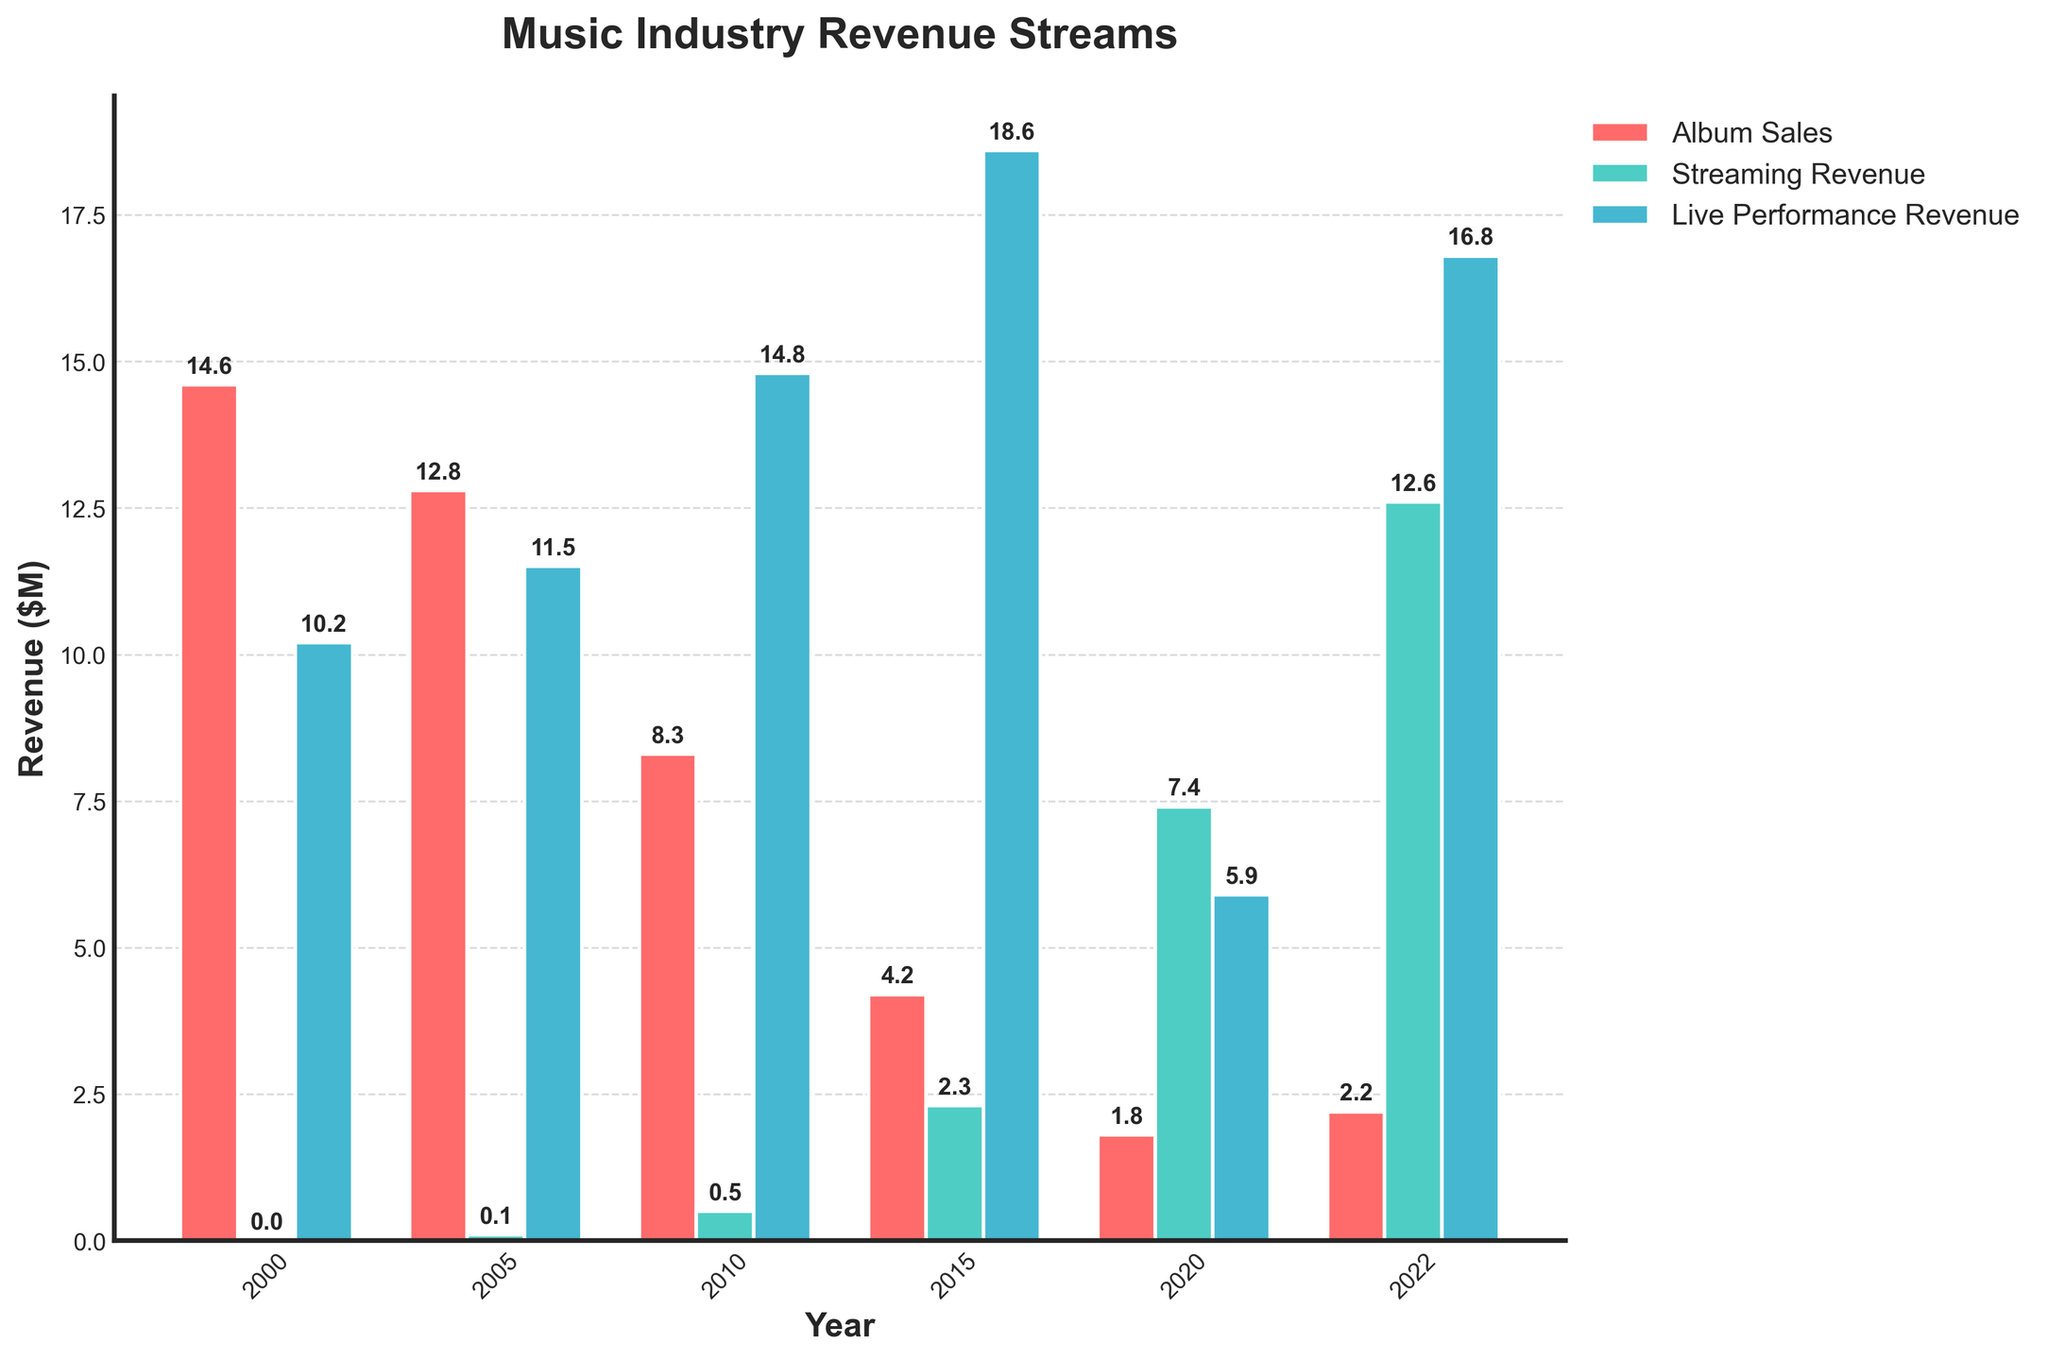What was the revenue from album sales in 2000? The bar representing album sales in the year 2000 shows a height labeling of 14.6.
Answer: 14.6 Which year had the highest streaming revenue? Among the bars representing streaming revenue across all the years, the highest bar is in 2022, labeled 12.6.
Answer: 2022 How did the revenue from live performances in 2005 compare to that in 2020? The bar for live performance revenue in 2005 is 11.5, and the bar in 2020 is 5.9. By comparing them, we see that revenue was higher in 2005.
Answer: Higher in 2005 Which revenue stream showed the most consistent increase over the years? Streaming revenue started from almost zero in 2000 and consistently increased to 12.6 by 2022. Both album sales and live performance revenue fluctuated.
Answer: Streaming revenue What is the difference between the album sales revenue and live performance revenue in 2010? The album sales revenue in 2010 is 8.3, and the live performance revenue is 14.8. The difference is 14.8 - 8.3.
Answer: 6.5 How much more was the streaming revenue compared to album sales in 2020? In 2020, streaming revenue was 7.4, and album sales were 1.8. The difference is 7.4 - 1.8.
Answer: 5.6 What is the average album sales revenue across all the given years? The album sales revenues are 14.6, 12.8, 8.3, 4.2, 1.8, and 2.2. The sum is 43.9, and there are 6 values. So, the average is 43.9/6.
Answer: 7.32 In which year did the live performance revenue surpass album sales by the largest margin? By visually comparing the bar heights for each year, in 2015 live performance revenue is 18.6 and album sales are 4.2, where the margin is widest. The difference is 18.6 - 4.2.
Answer: 2015 What is the total revenue from streaming and live performances in 2015? Streaming revenue in 2015 is 2.3, and live performance revenue is 18.6. The sum is 2.3 + 18.6.
Answer: 20.9 How much did the live performance revenue decrease from 2015 to 2020? Live performance revenue in 2015 is 18.6, and in 2020 it is 5.9. The decrease is 18.6 - 5.9.
Answer: 12.7 